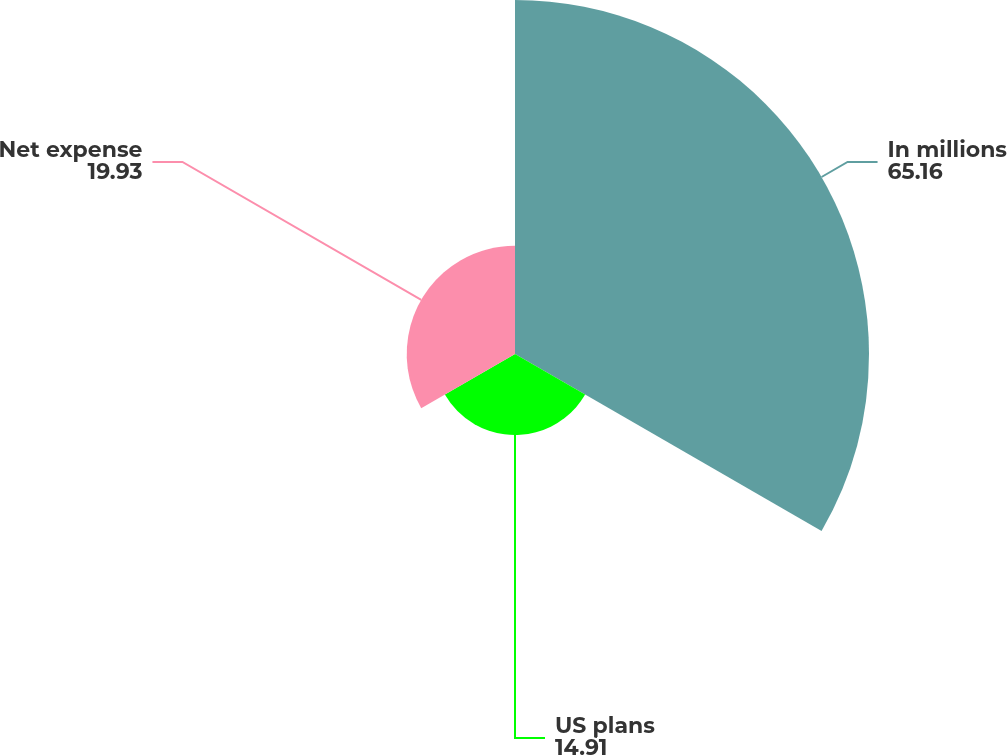Convert chart. <chart><loc_0><loc_0><loc_500><loc_500><pie_chart><fcel>In millions<fcel>US plans<fcel>Net expense<nl><fcel>65.16%<fcel>14.91%<fcel>19.93%<nl></chart> 